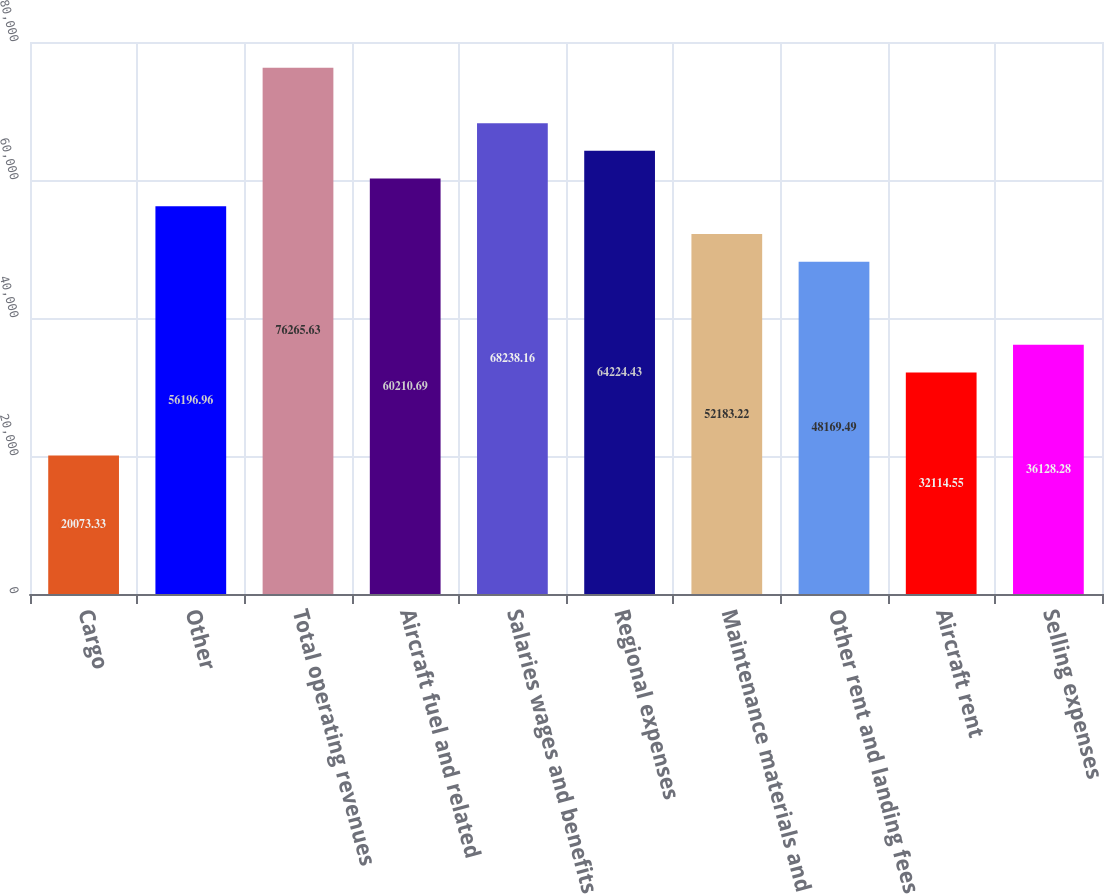<chart> <loc_0><loc_0><loc_500><loc_500><bar_chart><fcel>Cargo<fcel>Other<fcel>Total operating revenues<fcel>Aircraft fuel and related<fcel>Salaries wages and benefits<fcel>Regional expenses<fcel>Maintenance materials and<fcel>Other rent and landing fees<fcel>Aircraft rent<fcel>Selling expenses<nl><fcel>20073.3<fcel>56197<fcel>76265.6<fcel>60210.7<fcel>68238.2<fcel>64224.4<fcel>52183.2<fcel>48169.5<fcel>32114.5<fcel>36128.3<nl></chart> 